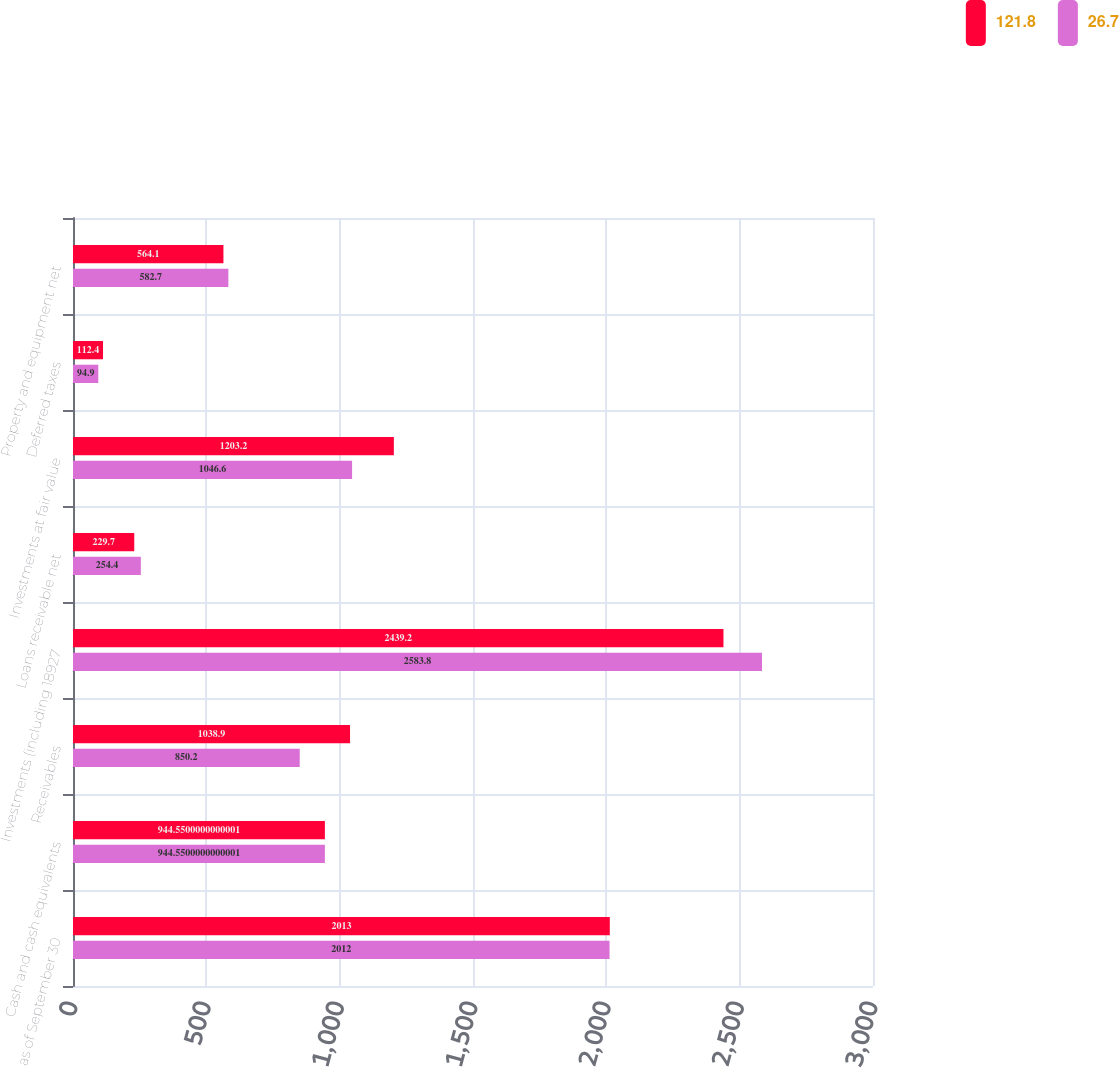<chart> <loc_0><loc_0><loc_500><loc_500><stacked_bar_chart><ecel><fcel>as of September 30<fcel>Cash and cash equivalents<fcel>Receivables<fcel>Investments (including 18927<fcel>Loans receivable net<fcel>Investments at fair value<fcel>Deferred taxes<fcel>Property and equipment net<nl><fcel>121.8<fcel>2013<fcel>944.55<fcel>1038.9<fcel>2439.2<fcel>229.7<fcel>1203.2<fcel>112.4<fcel>564.1<nl><fcel>26.7<fcel>2012<fcel>944.55<fcel>850.2<fcel>2583.8<fcel>254.4<fcel>1046.6<fcel>94.9<fcel>582.7<nl></chart> 